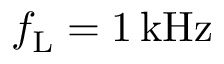<formula> <loc_0><loc_0><loc_500><loc_500>f _ { L } = 1 \, k H z</formula> 